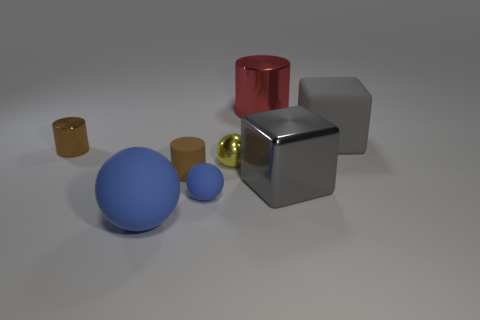Is the big red cylinder made of the same material as the tiny brown thing that is on the right side of the large blue object?
Make the answer very short. No. What is the size of the cube that is the same material as the tiny blue ball?
Provide a succinct answer. Large. There is a shiny cylinder that is left of the small blue ball; how big is it?
Your answer should be very brief. Small. What number of matte things are the same size as the brown rubber cylinder?
Give a very brief answer. 1. What size is the metallic cube that is the same color as the rubber block?
Make the answer very short. Large. Are there any small balls that have the same color as the big ball?
Offer a terse response. Yes. What is the color of the sphere that is the same size as the red shiny cylinder?
Your answer should be compact. Blue. Do the matte block and the large metal thing that is in front of the tiny brown rubber thing have the same color?
Give a very brief answer. Yes. The small shiny ball is what color?
Provide a succinct answer. Yellow. What is the large gray block that is on the left side of the gray rubber thing made of?
Your response must be concise. Metal. 